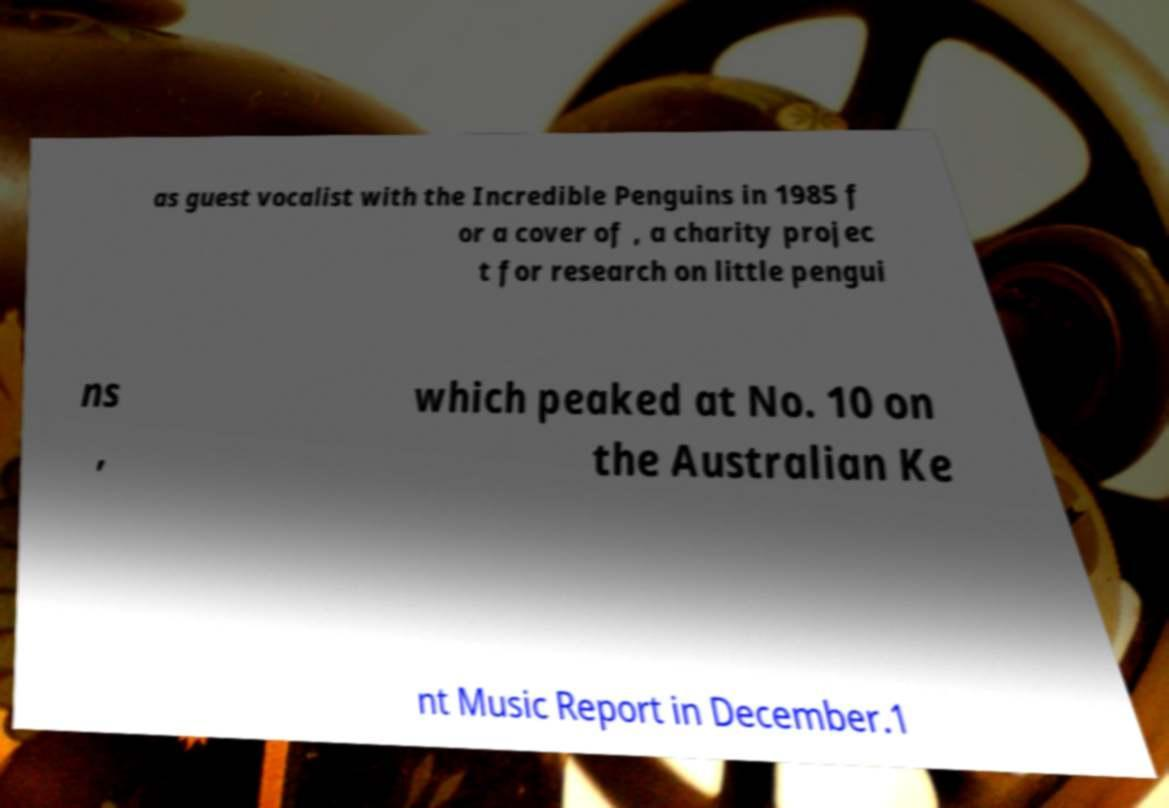For documentation purposes, I need the text within this image transcribed. Could you provide that? as guest vocalist with the Incredible Penguins in 1985 f or a cover of , a charity projec t for research on little pengui ns , which peaked at No. 10 on the Australian Ke nt Music Report in December.1 